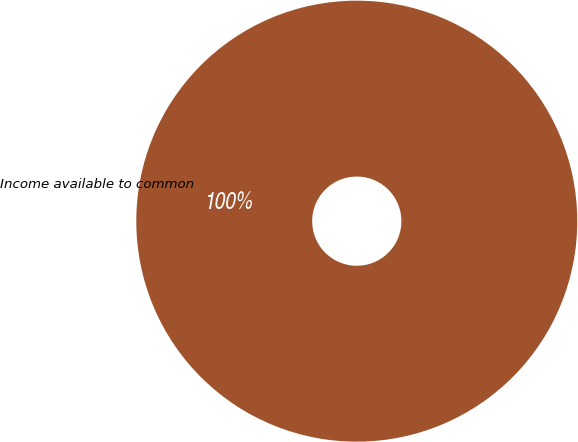Convert chart. <chart><loc_0><loc_0><loc_500><loc_500><pie_chart><fcel>Income available to common<nl><fcel>100.0%<nl></chart> 